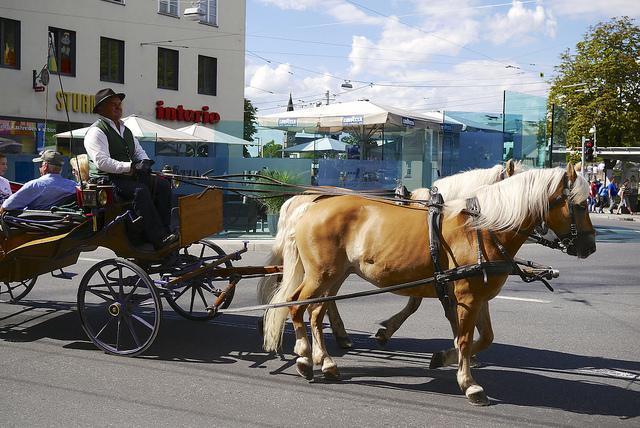How many animals are visible?
Give a very brief answer. 2. How many people are visible?
Give a very brief answer. 2. How many horses can be seen?
Give a very brief answer. 2. 